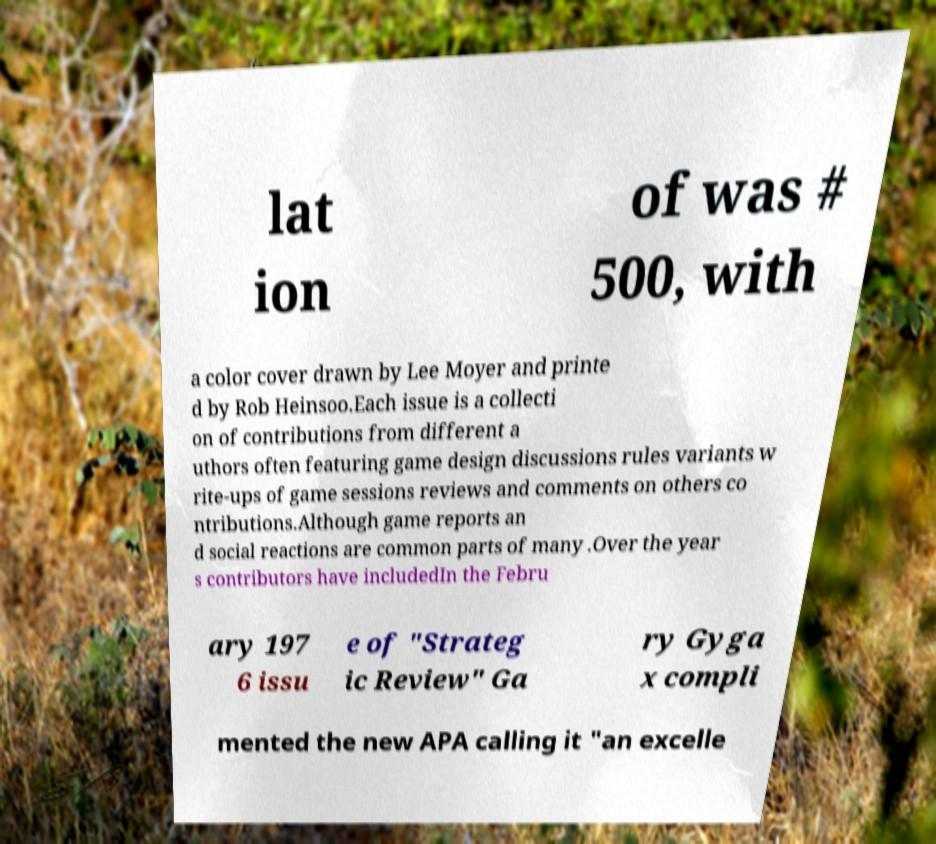Can you accurately transcribe the text from the provided image for me? lat ion of was # 500, with a color cover drawn by Lee Moyer and printe d by Rob Heinsoo.Each issue is a collecti on of contributions from different a uthors often featuring game design discussions rules variants w rite-ups of game sessions reviews and comments on others co ntributions.Although game reports an d social reactions are common parts of many .Over the year s contributors have includedIn the Febru ary 197 6 issu e of "Strateg ic Review" Ga ry Gyga x compli mented the new APA calling it "an excelle 